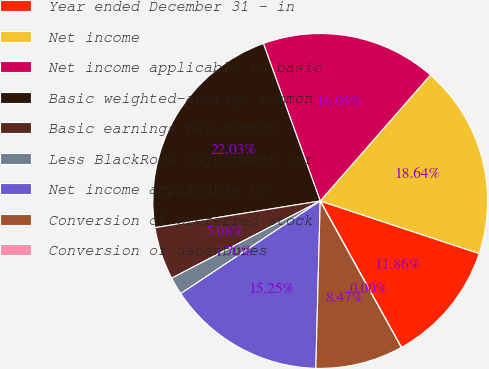<chart> <loc_0><loc_0><loc_500><loc_500><pie_chart><fcel>Year ended December 31 - in<fcel>Net income<fcel>Net income applicable to basic<fcel>Basic weighted-average common<fcel>Basic earnings per common<fcel>Less BlackRock adjustment for<fcel>Net income applicable to<fcel>Conversion of preferred stock<fcel>Conversion of debentures<nl><fcel>11.86%<fcel>18.64%<fcel>16.95%<fcel>22.03%<fcel>5.08%<fcel>1.7%<fcel>15.25%<fcel>8.47%<fcel>0.0%<nl></chart> 